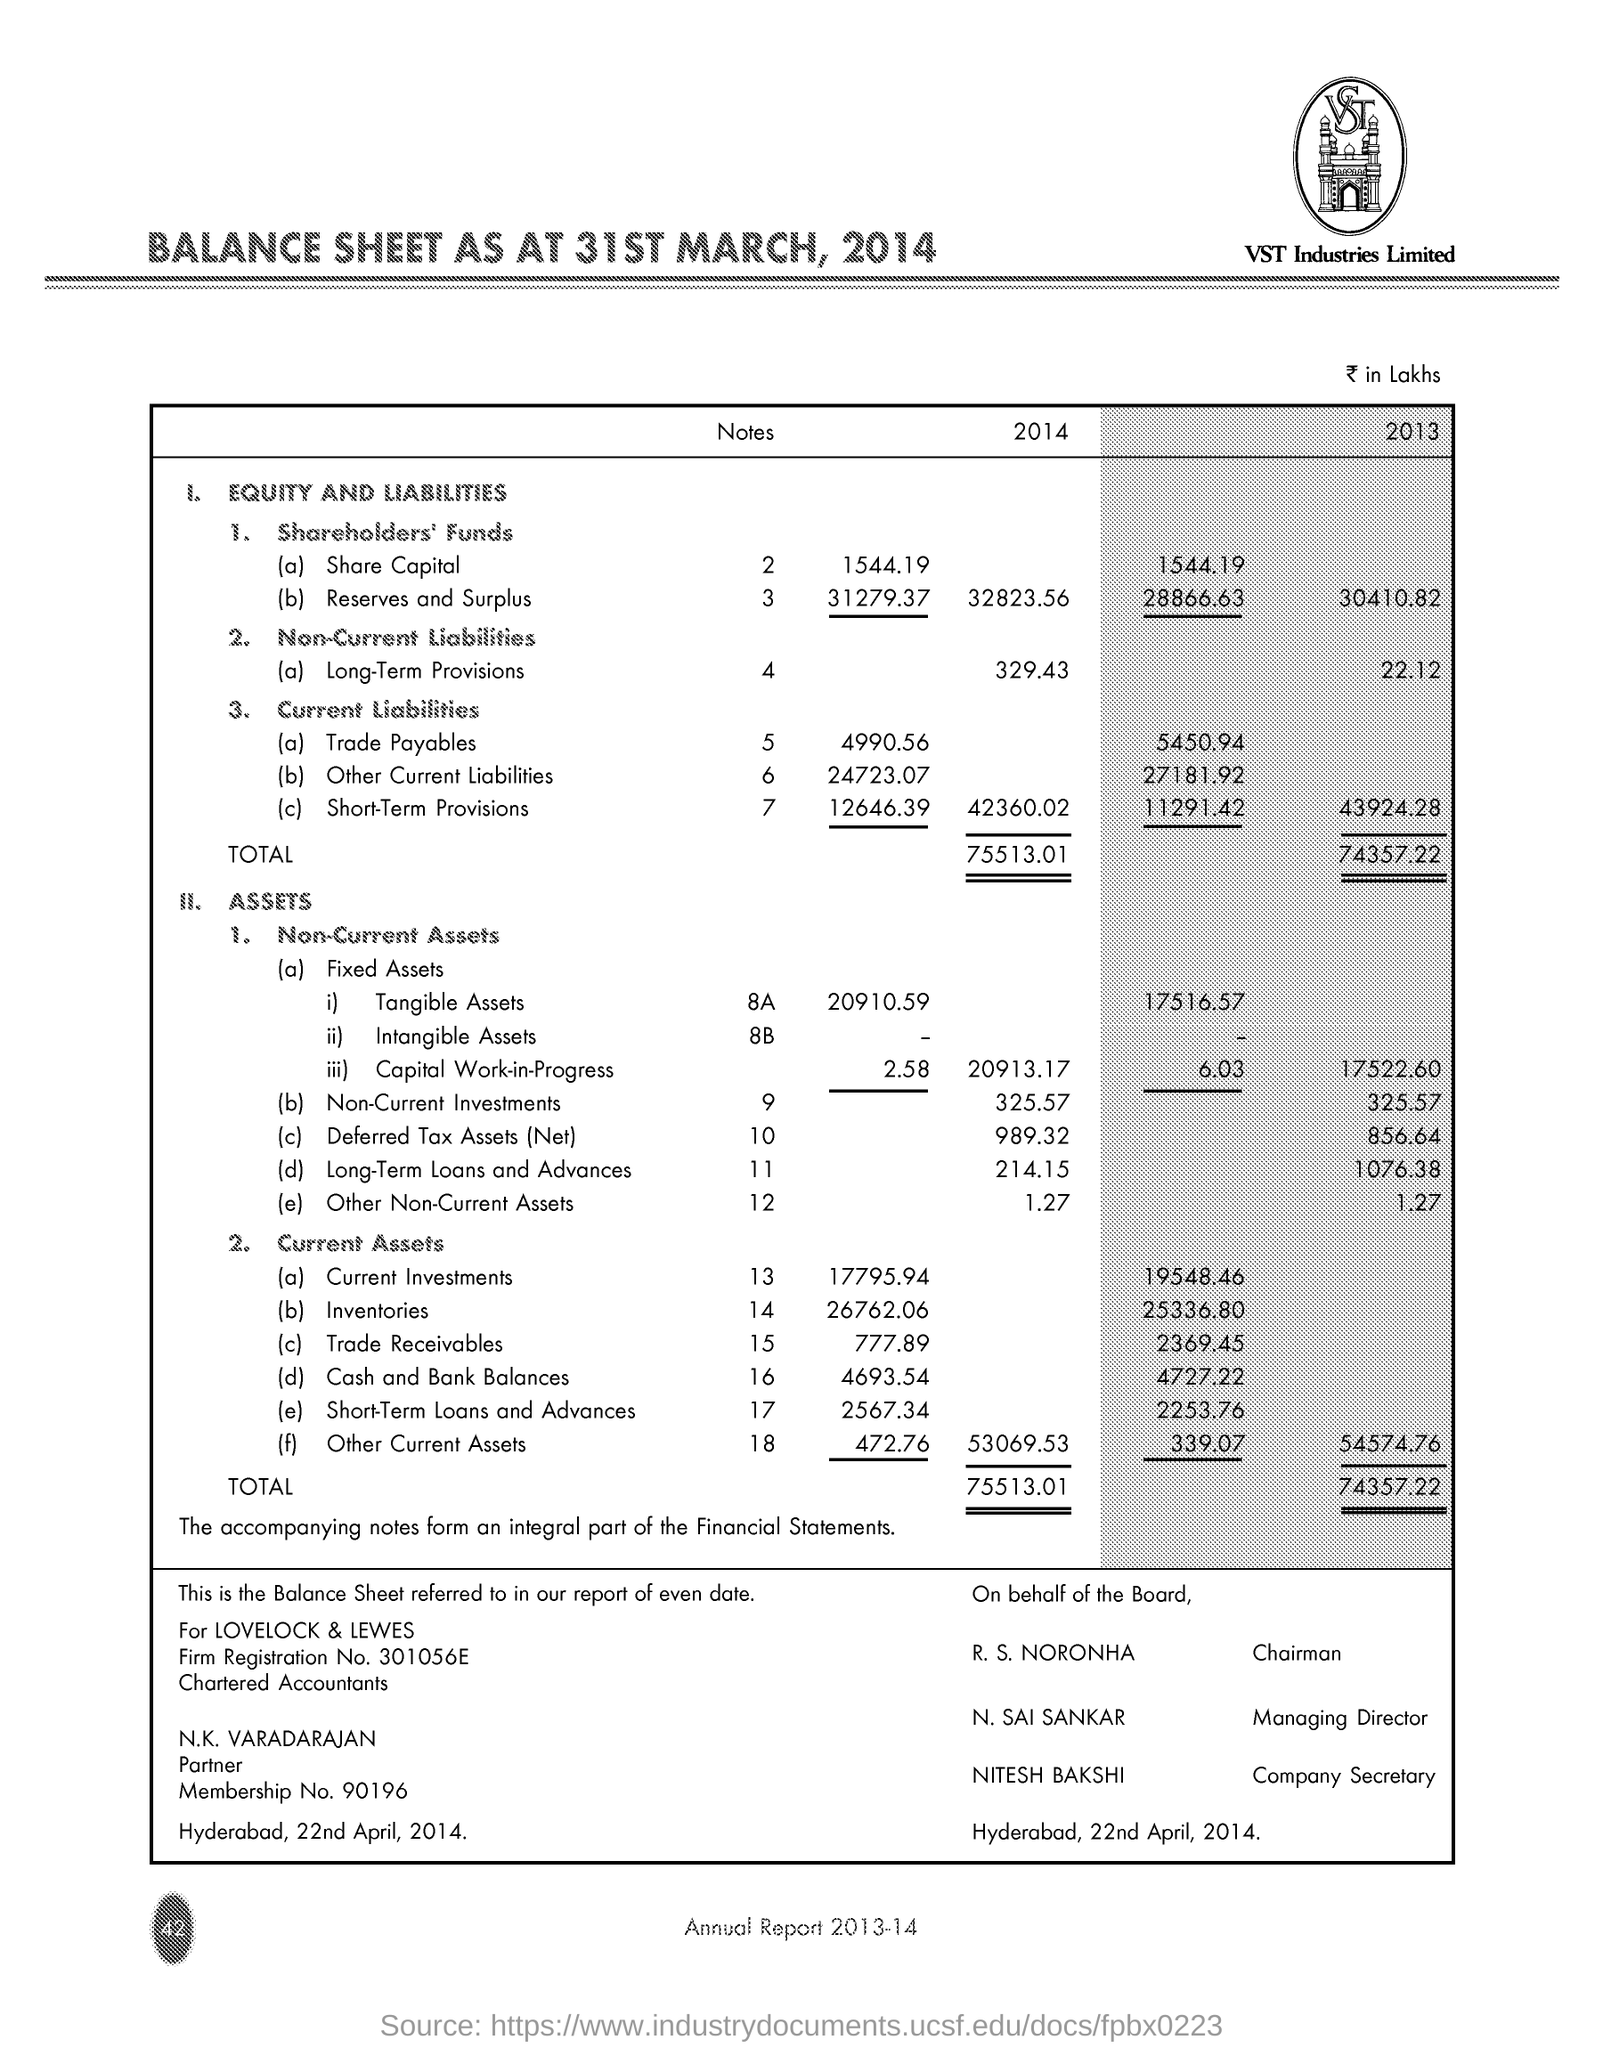When is the document dated on?
Your answer should be compact. 22nd April, 2014. What is the Place name on the document?
Provide a short and direct response. Hyderabad. What is the "Total" Assets for 2014?
Give a very brief answer. 75513.01. What is the "Total" Assets for 2013?
Ensure brevity in your answer.  74357.22. Who is the Managing Director?
Your answer should be very brief. N. Sai Sankar. Who is the Chairman?
Ensure brevity in your answer.  R. S. Noronha. Who is the Company Secretary?
Give a very brief answer. Nitesh Bakshi. 